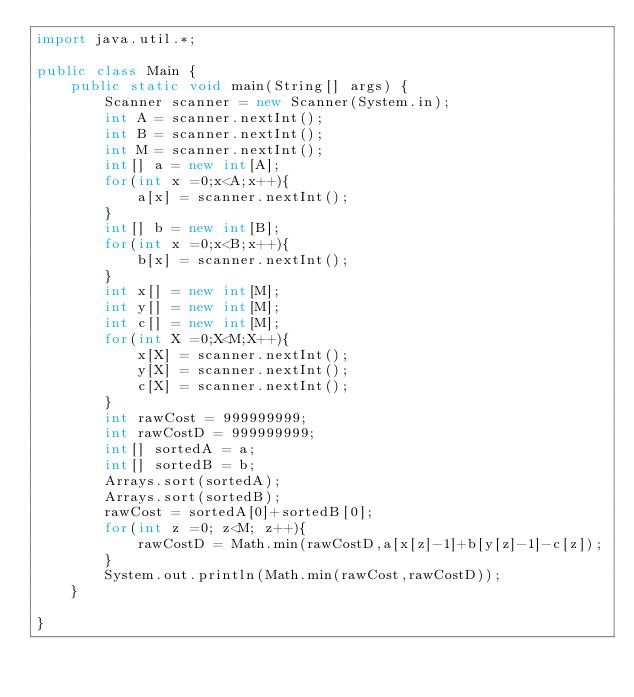<code> <loc_0><loc_0><loc_500><loc_500><_Java_>import java.util.*;

public class Main {
    public static void main(String[] args) {
        Scanner scanner = new Scanner(System.in);
        int A = scanner.nextInt();
        int B = scanner.nextInt();
        int M = scanner.nextInt();
        int[] a = new int[A];
        for(int x =0;x<A;x++){
            a[x] = scanner.nextInt();
        }
        int[] b = new int[B];
        for(int x =0;x<B;x++){
            b[x] = scanner.nextInt();
        }
        int x[] = new int[M];
        int y[] = new int[M];
        int c[] = new int[M];
        for(int X =0;X<M;X++){
            x[X] = scanner.nextInt();
            y[X] = scanner.nextInt();
            c[X] = scanner.nextInt();
        }
        int rawCost = 999999999;
        int rawCostD = 999999999;
        int[] sortedA = a;
        int[] sortedB = b;
        Arrays.sort(sortedA);
        Arrays.sort(sortedB);
        rawCost = sortedA[0]+sortedB[0];
        for(int z =0; z<M; z++){
            rawCostD = Math.min(rawCostD,a[x[z]-1]+b[y[z]-1]-c[z]);
        }
        System.out.println(Math.min(rawCost,rawCostD));
    }

}
</code> 